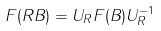Convert formula to latex. <formula><loc_0><loc_0><loc_500><loc_500>F ( R B ) = U _ { R } F ( B ) U ^ { - 1 } _ { R }</formula> 